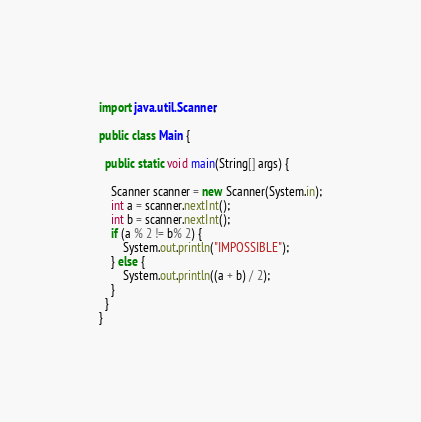<code> <loc_0><loc_0><loc_500><loc_500><_Java_>import java.util.Scanner;

public class Main {

  public static void main(String[] args) {

    Scanner scanner = new Scanner(System.in);
    int a = scanner.nextInt();
    int b = scanner.nextInt();
    if (a % 2 != b% 2) {
    	System.out.println("IMPOSSIBLE");
    } else {
    	System.out.println((a + b) / 2);
    }
  }
}
</code> 